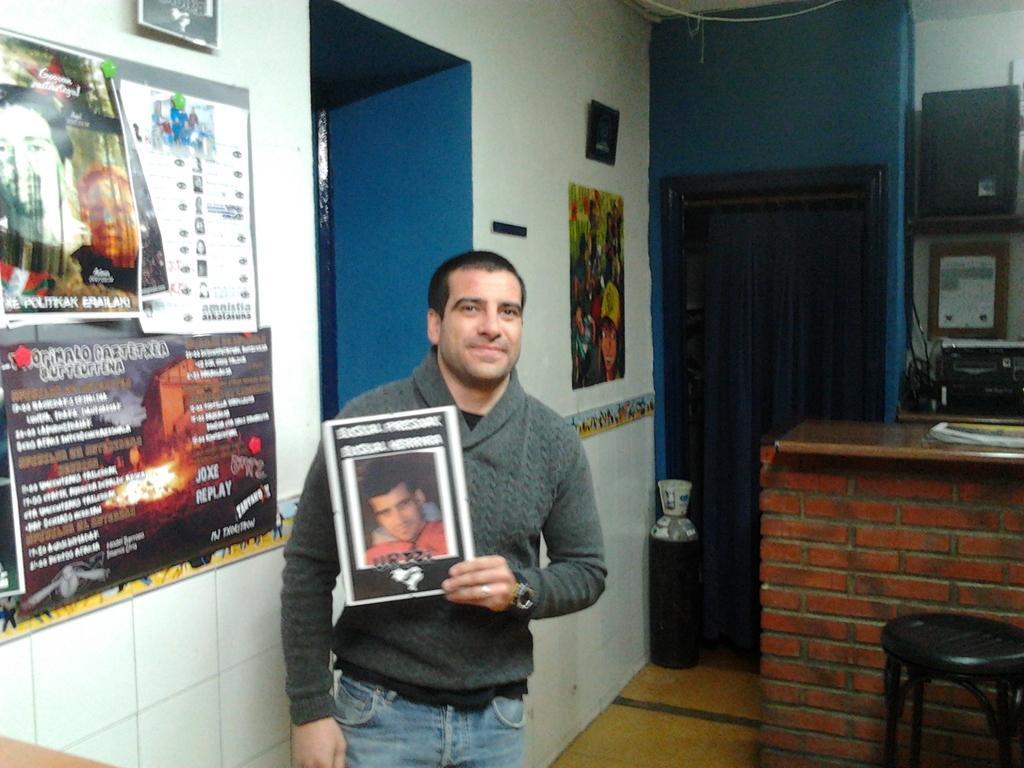Can you describe this image briefly? In this picture person is standing by holding the photograph. At the left side of the image there is a wall and few posters were attached to the wall. At the right side there is a chair. Behind the chair there is a wall. On top of the wall there are few objects. At the center there is a door and curtains were attached to it. 